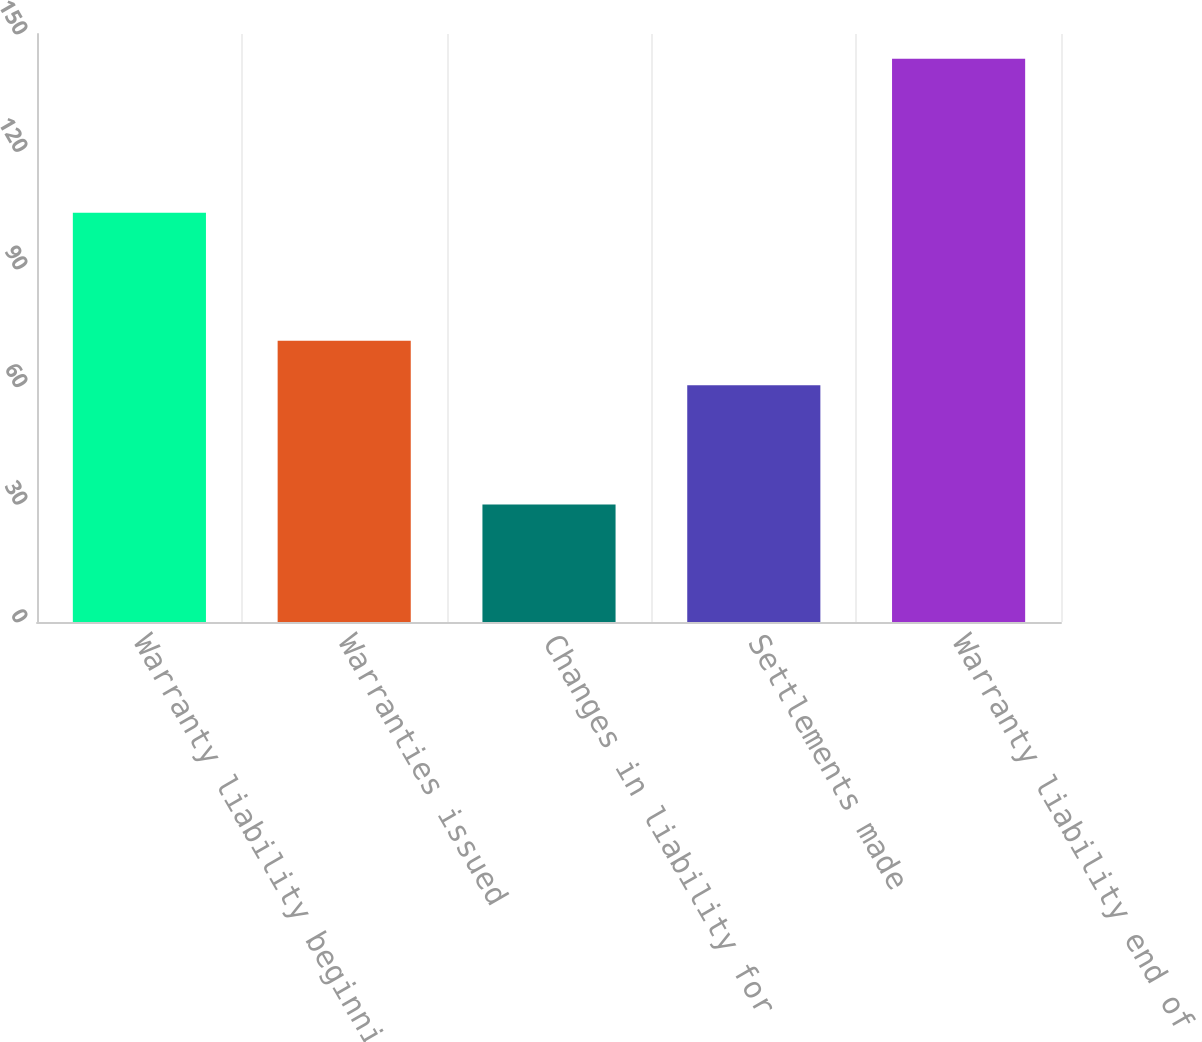Convert chart. <chart><loc_0><loc_0><loc_500><loc_500><bar_chart><fcel>Warranty liability beginning<fcel>Warranties issued<fcel>Changes in liability for<fcel>Settlements made<fcel>Warranty liability end of year<nl><fcel>104.4<fcel>71.77<fcel>30<fcel>60.4<fcel>143.7<nl></chart> 